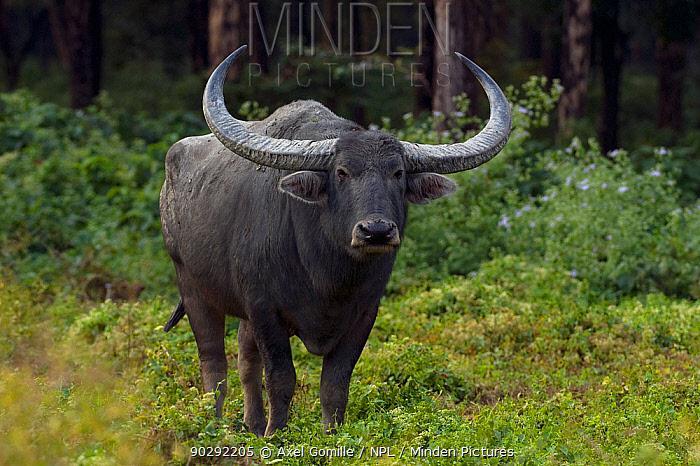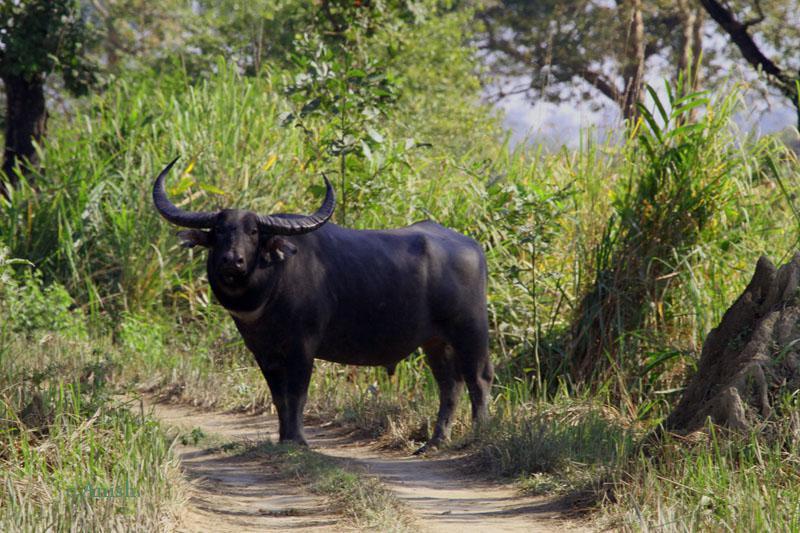The first image is the image on the left, the second image is the image on the right. Examine the images to the left and right. Is the description "There are exactly two water buffalos with one of them facing leftward." accurate? Answer yes or no. Yes. 